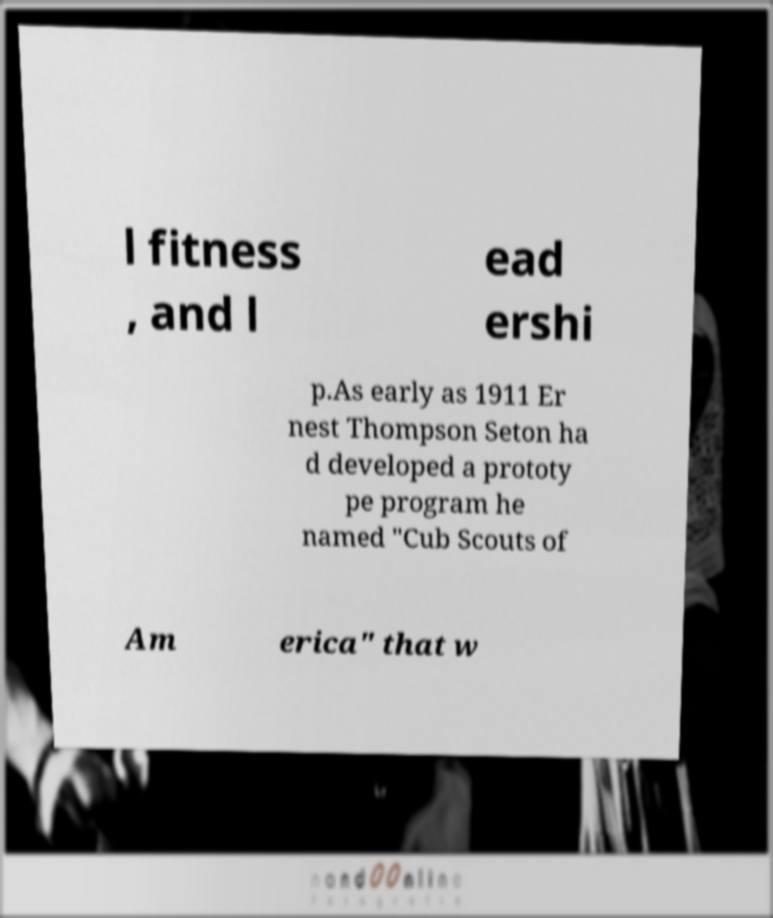Can you accurately transcribe the text from the provided image for me? l fitness , and l ead ershi p.As early as 1911 Er nest Thompson Seton ha d developed a prototy pe program he named "Cub Scouts of Am erica" that w 